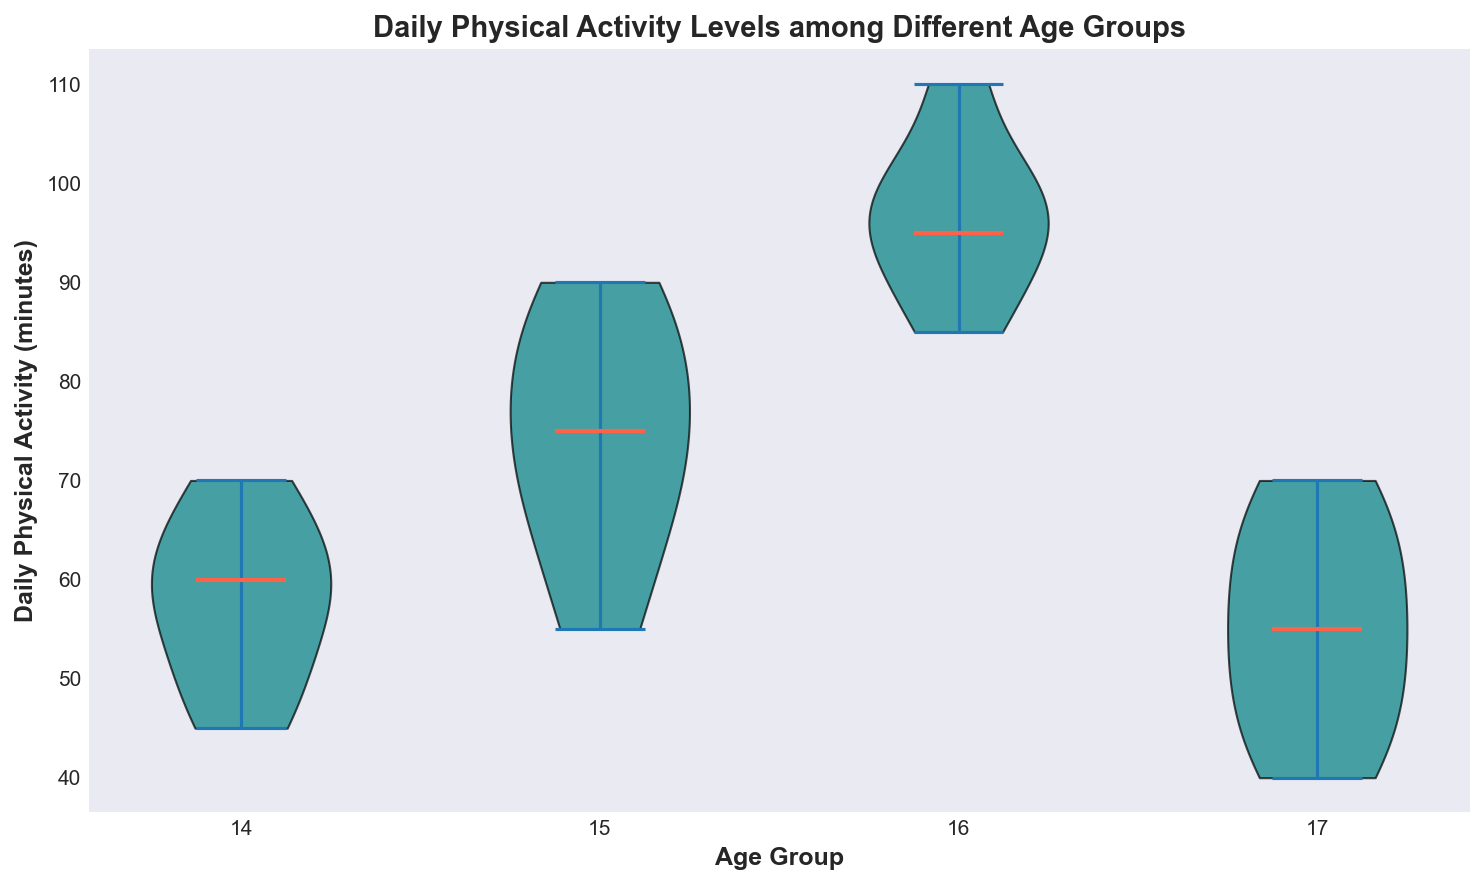What's the median daily physical activity level for the 16-year-old group? The violin plot shows a red line representing the median. For the 16-year-old group, this red line is positioned around 95 minutes.
Answer: 95 minutes Between which age groups is the difference in median activity levels most significant? The median is represented by the red line inside each violin. Observing these lines, the difference between 16-year-olds (95 minutes) and 17-year-olds (50 minutes) seems the most significant.
Answer: 16-year-olds and 17-year-olds What is the range of daily physical activity levels for 15-year-olds? The spread of the violin plot for 15-year-olds ranges from the lowest point to the highest point. The 15-year-old group ranges from about 55 minutes to 90 minutes.
Answer: 55 to 90 minutes Which age group exhibits the greatest variability in daily physical activity levels? The variability is visible in the width and spread of the violin plot. The 16-year-old group shows the most significant spread, indicating the greatest variability.
Answer: 16-year-olds How does the physical activity level for 14-year-olds compare to that of 17-year-olds? By examining the medians, we can see that the 14-year-olds have a median around 60 minutes, whereas 17-year-olds have a median around 50 minutes. The 14-year-olds are generally more active.
Answer: 14-year-olds are generally more active than 17-year-olds Which age group appears to have the least variability in daily physical activity levels? The least variability is shown by the group with the smallest spread in their violin plot. In this case, the 17-year-olds show the least variability.
Answer: 17-year-olds Is there an age group where the median physical activity level is over 1.5 hours? Convert 1.5 hours to minutes, which is 90 minutes. The median of the 16-year-olds is at 95 minutes, which is above 90 minutes.
Answer: Yes, the 16-year-olds What is the approximate interquartile range (IQR) for the 14-year-old group? The IQR can be visualized as the middle 50% of the data points. For the 14-year-old group, this appears to range from around 50 to 65 minutes. Thus, the IQR is roughly 65 - 50 = 15 minutes.
Answer: 15 minutes In which age group is the median activity level below 1 hour? The red median line for the 17-year-olds is around 50 minutes, which is below 1 hour (60 minutes).
Answer: 17-year-olds Which age group has the highest median level of physical activity? Identifying the highest red median line shows that the 16-year-olds have the highest median activity level at 95 minutes.
Answer: 16-year-olds 